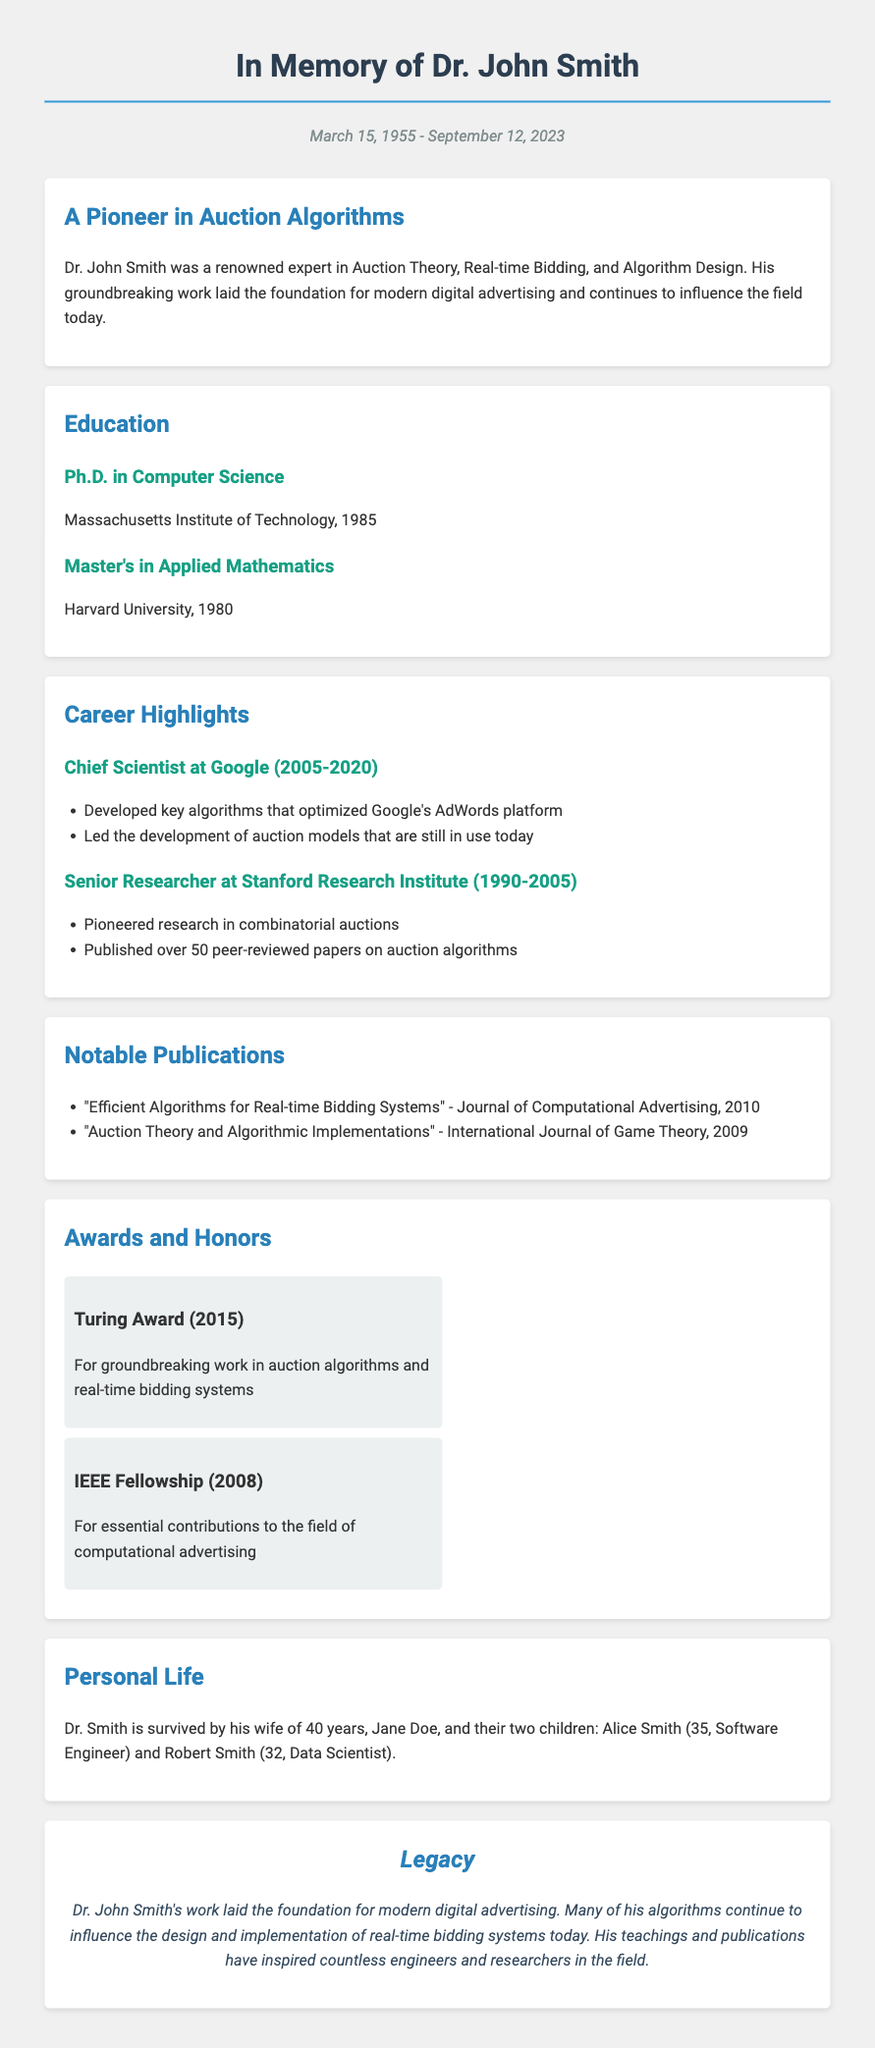What is the full name of the pioneer in auction algorithms? The document states the full name as Dr. John Smith.
Answer: Dr. John Smith When was Dr. John Smith born? The document provides the birth date as March 15, 1955.
Answer: March 15, 1955 What prestigious award did he win in 2015? The document mentions the Turing Award as the award won in 2015.
Answer: Turing Award Which university did Dr. Smith obtain his Ph.D. from? The document states that he obtained his Ph.D. from the Massachusetts Institute of Technology.
Answer: Massachusetts Institute of Technology How many peer-reviewed papers did Dr. Smith publish? The document mentions that he published over 50 peer-reviewed papers.
Answer: Over 50 What position did Dr. Smith hold at Google? The document states he was the Chief Scientist at Google.
Answer: Chief Scientist What is the legacy left by Dr. John Smith? The document describes his legacy as laying the foundation for modern digital advertising.
Answer: Foundation for modern digital advertising Who survived Dr. Smith? The document lists his wife, Jane Doe, and their two children, Alice and Robert.
Answer: Jane Doe, Alice Smith, Robert Smith What area of research did he pioneer at the Stanford Research Institute? The document states he pioneered research in combinatorial auctions.
Answer: Combinatorial auctions 